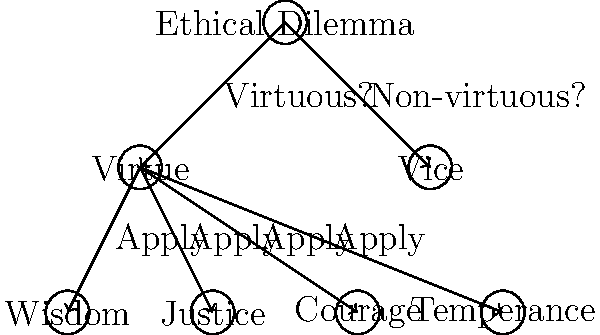In the decision tree shown, how can a Stoic practitioner use this framework to navigate a modern ethical dilemma? Which cardinal virtue should be primarily considered when facing a situation that challenges one's integrity in a professional setting? To navigate a modern ethical dilemma using this Stoic decision tree, follow these steps:

1. Identify the ethical dilemma at the root of the tree.
2. Determine whether the potential action is virtuous or non-virtuous.
3. If virtuous, proceed to apply the four cardinal virtues of Stoicism:
   a. Wisdom (Sophia): Practical wisdom and good judgment
   b. Justice (Dikaiosyne): Fairness and moral rightness
   c. Courage (Andreia): Bravery in the face of adversity
   d. Temperance (Sophrosyne): Self-control and moderation

4. In a professional setting where one's integrity is challenged:
   a. Wisdom helps in understanding the complexity of the situation
   b. Justice ensures fair treatment and ethical behavior
   c. Courage is needed to stand up for what's right
   d. Temperance helps in maintaining composure and avoiding rash decisions

5. For this specific scenario, the primary virtue to consider is Justice (Dikaiosyne).

Justice is most relevant because:
- It directly relates to ethical behavior and moral rightness in professional contexts
- It guides decisions that affect others and the broader community
- It helps maintain integrity by ensuring fair and honest actions
- It aligns with professional ethics and codes of conduct

While all virtues are interconnected and important, Justice provides the strongest foundation for maintaining integrity in a professional setting.
Answer: Justice (Dikaiosyne) 